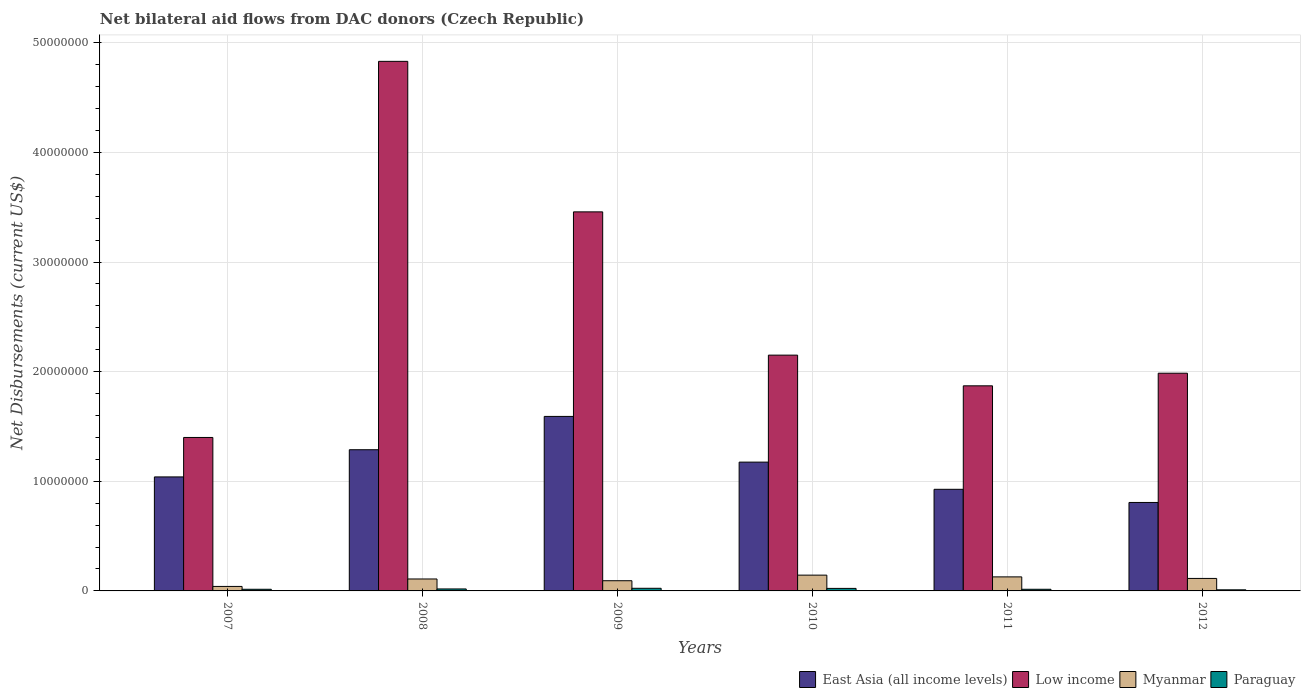How many different coloured bars are there?
Ensure brevity in your answer.  4. How many groups of bars are there?
Offer a very short reply. 6. Are the number of bars per tick equal to the number of legend labels?
Offer a very short reply. Yes. What is the label of the 1st group of bars from the left?
Provide a short and direct response. 2007. What is the net bilateral aid flows in East Asia (all income levels) in 2010?
Give a very brief answer. 1.18e+07. Across all years, what is the maximum net bilateral aid flows in Paraguay?
Your response must be concise. 2.40e+05. Across all years, what is the minimum net bilateral aid flows in Low income?
Offer a terse response. 1.40e+07. What is the total net bilateral aid flows in East Asia (all income levels) in the graph?
Keep it short and to the point. 6.83e+07. What is the difference between the net bilateral aid flows in East Asia (all income levels) in 2010 and that in 2011?
Keep it short and to the point. 2.48e+06. What is the difference between the net bilateral aid flows in East Asia (all income levels) in 2009 and the net bilateral aid flows in Paraguay in 2012?
Your response must be concise. 1.58e+07. What is the average net bilateral aid flows in Paraguay per year?
Provide a succinct answer. 1.75e+05. In the year 2008, what is the difference between the net bilateral aid flows in Paraguay and net bilateral aid flows in Low income?
Keep it short and to the point. -4.81e+07. In how many years, is the net bilateral aid flows in East Asia (all income levels) greater than 18000000 US$?
Make the answer very short. 0. What is the ratio of the net bilateral aid flows in Paraguay in 2009 to that in 2011?
Provide a short and direct response. 1.6. Is the net bilateral aid flows in Low income in 2009 less than that in 2012?
Make the answer very short. No. What is the difference between the highest and the second highest net bilateral aid flows in East Asia (all income levels)?
Your answer should be very brief. 3.04e+06. What is the difference between the highest and the lowest net bilateral aid flows in East Asia (all income levels)?
Make the answer very short. 7.85e+06. In how many years, is the net bilateral aid flows in Myanmar greater than the average net bilateral aid flows in Myanmar taken over all years?
Offer a very short reply. 4. Is the sum of the net bilateral aid flows in Paraguay in 2010 and 2012 greater than the maximum net bilateral aid flows in Myanmar across all years?
Give a very brief answer. No. What does the 4th bar from the left in 2009 represents?
Your answer should be compact. Paraguay. What does the 2nd bar from the right in 2007 represents?
Make the answer very short. Myanmar. How many bars are there?
Give a very brief answer. 24. How many years are there in the graph?
Offer a terse response. 6. What is the difference between two consecutive major ticks on the Y-axis?
Keep it short and to the point. 1.00e+07. Are the values on the major ticks of Y-axis written in scientific E-notation?
Keep it short and to the point. No. How many legend labels are there?
Offer a very short reply. 4. How are the legend labels stacked?
Your answer should be compact. Horizontal. What is the title of the graph?
Make the answer very short. Net bilateral aid flows from DAC donors (Czech Republic). What is the label or title of the Y-axis?
Keep it short and to the point. Net Disbursements (current US$). What is the Net Disbursements (current US$) of East Asia (all income levels) in 2007?
Provide a short and direct response. 1.04e+07. What is the Net Disbursements (current US$) in Low income in 2007?
Make the answer very short. 1.40e+07. What is the Net Disbursements (current US$) of East Asia (all income levels) in 2008?
Give a very brief answer. 1.29e+07. What is the Net Disbursements (current US$) in Low income in 2008?
Your response must be concise. 4.83e+07. What is the Net Disbursements (current US$) of Myanmar in 2008?
Offer a very short reply. 1.09e+06. What is the Net Disbursements (current US$) of Paraguay in 2008?
Offer a terse response. 1.80e+05. What is the Net Disbursements (current US$) in East Asia (all income levels) in 2009?
Provide a short and direct response. 1.59e+07. What is the Net Disbursements (current US$) in Low income in 2009?
Offer a very short reply. 3.46e+07. What is the Net Disbursements (current US$) in Myanmar in 2009?
Give a very brief answer. 9.30e+05. What is the Net Disbursements (current US$) in Paraguay in 2009?
Give a very brief answer. 2.40e+05. What is the Net Disbursements (current US$) in East Asia (all income levels) in 2010?
Your response must be concise. 1.18e+07. What is the Net Disbursements (current US$) in Low income in 2010?
Provide a succinct answer. 2.15e+07. What is the Net Disbursements (current US$) of Myanmar in 2010?
Provide a succinct answer. 1.44e+06. What is the Net Disbursements (current US$) of East Asia (all income levels) in 2011?
Make the answer very short. 9.27e+06. What is the Net Disbursements (current US$) of Low income in 2011?
Make the answer very short. 1.87e+07. What is the Net Disbursements (current US$) in Myanmar in 2011?
Give a very brief answer. 1.28e+06. What is the Net Disbursements (current US$) in Paraguay in 2011?
Your response must be concise. 1.50e+05. What is the Net Disbursements (current US$) of East Asia (all income levels) in 2012?
Make the answer very short. 8.07e+06. What is the Net Disbursements (current US$) of Low income in 2012?
Offer a very short reply. 1.99e+07. What is the Net Disbursements (current US$) of Myanmar in 2012?
Your response must be concise. 1.14e+06. Across all years, what is the maximum Net Disbursements (current US$) of East Asia (all income levels)?
Your response must be concise. 1.59e+07. Across all years, what is the maximum Net Disbursements (current US$) in Low income?
Make the answer very short. 4.83e+07. Across all years, what is the maximum Net Disbursements (current US$) of Myanmar?
Provide a succinct answer. 1.44e+06. Across all years, what is the maximum Net Disbursements (current US$) in Paraguay?
Offer a very short reply. 2.40e+05. Across all years, what is the minimum Net Disbursements (current US$) of East Asia (all income levels)?
Your response must be concise. 8.07e+06. Across all years, what is the minimum Net Disbursements (current US$) of Low income?
Ensure brevity in your answer.  1.40e+07. Across all years, what is the minimum Net Disbursements (current US$) of Myanmar?
Provide a succinct answer. 4.10e+05. Across all years, what is the minimum Net Disbursements (current US$) in Paraguay?
Give a very brief answer. 1.00e+05. What is the total Net Disbursements (current US$) of East Asia (all income levels) in the graph?
Offer a very short reply. 6.83e+07. What is the total Net Disbursements (current US$) of Low income in the graph?
Your answer should be very brief. 1.57e+08. What is the total Net Disbursements (current US$) in Myanmar in the graph?
Your answer should be very brief. 6.29e+06. What is the total Net Disbursements (current US$) in Paraguay in the graph?
Keep it short and to the point. 1.05e+06. What is the difference between the Net Disbursements (current US$) of East Asia (all income levels) in 2007 and that in 2008?
Give a very brief answer. -2.48e+06. What is the difference between the Net Disbursements (current US$) in Low income in 2007 and that in 2008?
Provide a succinct answer. -3.43e+07. What is the difference between the Net Disbursements (current US$) in Myanmar in 2007 and that in 2008?
Offer a terse response. -6.80e+05. What is the difference between the Net Disbursements (current US$) in East Asia (all income levels) in 2007 and that in 2009?
Provide a succinct answer. -5.52e+06. What is the difference between the Net Disbursements (current US$) in Low income in 2007 and that in 2009?
Ensure brevity in your answer.  -2.06e+07. What is the difference between the Net Disbursements (current US$) in Myanmar in 2007 and that in 2009?
Offer a terse response. -5.20e+05. What is the difference between the Net Disbursements (current US$) of East Asia (all income levels) in 2007 and that in 2010?
Ensure brevity in your answer.  -1.35e+06. What is the difference between the Net Disbursements (current US$) in Low income in 2007 and that in 2010?
Give a very brief answer. -7.51e+06. What is the difference between the Net Disbursements (current US$) in Myanmar in 2007 and that in 2010?
Your answer should be very brief. -1.03e+06. What is the difference between the Net Disbursements (current US$) of Paraguay in 2007 and that in 2010?
Your response must be concise. -8.00e+04. What is the difference between the Net Disbursements (current US$) in East Asia (all income levels) in 2007 and that in 2011?
Offer a terse response. 1.13e+06. What is the difference between the Net Disbursements (current US$) in Low income in 2007 and that in 2011?
Give a very brief answer. -4.71e+06. What is the difference between the Net Disbursements (current US$) of Myanmar in 2007 and that in 2011?
Offer a very short reply. -8.70e+05. What is the difference between the Net Disbursements (current US$) of East Asia (all income levels) in 2007 and that in 2012?
Your response must be concise. 2.33e+06. What is the difference between the Net Disbursements (current US$) in Low income in 2007 and that in 2012?
Ensure brevity in your answer.  -5.86e+06. What is the difference between the Net Disbursements (current US$) of Myanmar in 2007 and that in 2012?
Your answer should be compact. -7.30e+05. What is the difference between the Net Disbursements (current US$) of East Asia (all income levels) in 2008 and that in 2009?
Your response must be concise. -3.04e+06. What is the difference between the Net Disbursements (current US$) of Low income in 2008 and that in 2009?
Provide a succinct answer. 1.37e+07. What is the difference between the Net Disbursements (current US$) of Paraguay in 2008 and that in 2009?
Give a very brief answer. -6.00e+04. What is the difference between the Net Disbursements (current US$) of East Asia (all income levels) in 2008 and that in 2010?
Keep it short and to the point. 1.13e+06. What is the difference between the Net Disbursements (current US$) of Low income in 2008 and that in 2010?
Provide a short and direct response. 2.68e+07. What is the difference between the Net Disbursements (current US$) in Myanmar in 2008 and that in 2010?
Offer a very short reply. -3.50e+05. What is the difference between the Net Disbursements (current US$) in Paraguay in 2008 and that in 2010?
Keep it short and to the point. -5.00e+04. What is the difference between the Net Disbursements (current US$) in East Asia (all income levels) in 2008 and that in 2011?
Provide a short and direct response. 3.61e+06. What is the difference between the Net Disbursements (current US$) of Low income in 2008 and that in 2011?
Your answer should be very brief. 2.96e+07. What is the difference between the Net Disbursements (current US$) of East Asia (all income levels) in 2008 and that in 2012?
Ensure brevity in your answer.  4.81e+06. What is the difference between the Net Disbursements (current US$) in Low income in 2008 and that in 2012?
Your response must be concise. 2.84e+07. What is the difference between the Net Disbursements (current US$) in Myanmar in 2008 and that in 2012?
Your answer should be compact. -5.00e+04. What is the difference between the Net Disbursements (current US$) in Paraguay in 2008 and that in 2012?
Offer a very short reply. 8.00e+04. What is the difference between the Net Disbursements (current US$) in East Asia (all income levels) in 2009 and that in 2010?
Provide a short and direct response. 4.17e+06. What is the difference between the Net Disbursements (current US$) of Low income in 2009 and that in 2010?
Offer a very short reply. 1.31e+07. What is the difference between the Net Disbursements (current US$) of Myanmar in 2009 and that in 2010?
Make the answer very short. -5.10e+05. What is the difference between the Net Disbursements (current US$) of East Asia (all income levels) in 2009 and that in 2011?
Make the answer very short. 6.65e+06. What is the difference between the Net Disbursements (current US$) in Low income in 2009 and that in 2011?
Keep it short and to the point. 1.59e+07. What is the difference between the Net Disbursements (current US$) of Myanmar in 2009 and that in 2011?
Your answer should be compact. -3.50e+05. What is the difference between the Net Disbursements (current US$) of Paraguay in 2009 and that in 2011?
Your response must be concise. 9.00e+04. What is the difference between the Net Disbursements (current US$) in East Asia (all income levels) in 2009 and that in 2012?
Give a very brief answer. 7.85e+06. What is the difference between the Net Disbursements (current US$) of Low income in 2009 and that in 2012?
Ensure brevity in your answer.  1.47e+07. What is the difference between the Net Disbursements (current US$) of Paraguay in 2009 and that in 2012?
Give a very brief answer. 1.40e+05. What is the difference between the Net Disbursements (current US$) of East Asia (all income levels) in 2010 and that in 2011?
Offer a very short reply. 2.48e+06. What is the difference between the Net Disbursements (current US$) of Low income in 2010 and that in 2011?
Provide a succinct answer. 2.80e+06. What is the difference between the Net Disbursements (current US$) of Myanmar in 2010 and that in 2011?
Give a very brief answer. 1.60e+05. What is the difference between the Net Disbursements (current US$) of East Asia (all income levels) in 2010 and that in 2012?
Make the answer very short. 3.68e+06. What is the difference between the Net Disbursements (current US$) of Low income in 2010 and that in 2012?
Your answer should be compact. 1.65e+06. What is the difference between the Net Disbursements (current US$) of Myanmar in 2010 and that in 2012?
Provide a succinct answer. 3.00e+05. What is the difference between the Net Disbursements (current US$) of Paraguay in 2010 and that in 2012?
Offer a terse response. 1.30e+05. What is the difference between the Net Disbursements (current US$) in East Asia (all income levels) in 2011 and that in 2012?
Make the answer very short. 1.20e+06. What is the difference between the Net Disbursements (current US$) in Low income in 2011 and that in 2012?
Give a very brief answer. -1.15e+06. What is the difference between the Net Disbursements (current US$) in Myanmar in 2011 and that in 2012?
Provide a short and direct response. 1.40e+05. What is the difference between the Net Disbursements (current US$) in East Asia (all income levels) in 2007 and the Net Disbursements (current US$) in Low income in 2008?
Your answer should be compact. -3.79e+07. What is the difference between the Net Disbursements (current US$) of East Asia (all income levels) in 2007 and the Net Disbursements (current US$) of Myanmar in 2008?
Your answer should be compact. 9.31e+06. What is the difference between the Net Disbursements (current US$) in East Asia (all income levels) in 2007 and the Net Disbursements (current US$) in Paraguay in 2008?
Provide a short and direct response. 1.02e+07. What is the difference between the Net Disbursements (current US$) in Low income in 2007 and the Net Disbursements (current US$) in Myanmar in 2008?
Your response must be concise. 1.29e+07. What is the difference between the Net Disbursements (current US$) of Low income in 2007 and the Net Disbursements (current US$) of Paraguay in 2008?
Your answer should be very brief. 1.38e+07. What is the difference between the Net Disbursements (current US$) of East Asia (all income levels) in 2007 and the Net Disbursements (current US$) of Low income in 2009?
Provide a short and direct response. -2.42e+07. What is the difference between the Net Disbursements (current US$) of East Asia (all income levels) in 2007 and the Net Disbursements (current US$) of Myanmar in 2009?
Offer a very short reply. 9.47e+06. What is the difference between the Net Disbursements (current US$) in East Asia (all income levels) in 2007 and the Net Disbursements (current US$) in Paraguay in 2009?
Your answer should be compact. 1.02e+07. What is the difference between the Net Disbursements (current US$) of Low income in 2007 and the Net Disbursements (current US$) of Myanmar in 2009?
Give a very brief answer. 1.31e+07. What is the difference between the Net Disbursements (current US$) of Low income in 2007 and the Net Disbursements (current US$) of Paraguay in 2009?
Your answer should be compact. 1.38e+07. What is the difference between the Net Disbursements (current US$) in East Asia (all income levels) in 2007 and the Net Disbursements (current US$) in Low income in 2010?
Keep it short and to the point. -1.11e+07. What is the difference between the Net Disbursements (current US$) in East Asia (all income levels) in 2007 and the Net Disbursements (current US$) in Myanmar in 2010?
Keep it short and to the point. 8.96e+06. What is the difference between the Net Disbursements (current US$) in East Asia (all income levels) in 2007 and the Net Disbursements (current US$) in Paraguay in 2010?
Keep it short and to the point. 1.02e+07. What is the difference between the Net Disbursements (current US$) of Low income in 2007 and the Net Disbursements (current US$) of Myanmar in 2010?
Ensure brevity in your answer.  1.26e+07. What is the difference between the Net Disbursements (current US$) in Low income in 2007 and the Net Disbursements (current US$) in Paraguay in 2010?
Keep it short and to the point. 1.38e+07. What is the difference between the Net Disbursements (current US$) in Myanmar in 2007 and the Net Disbursements (current US$) in Paraguay in 2010?
Give a very brief answer. 1.80e+05. What is the difference between the Net Disbursements (current US$) of East Asia (all income levels) in 2007 and the Net Disbursements (current US$) of Low income in 2011?
Keep it short and to the point. -8.31e+06. What is the difference between the Net Disbursements (current US$) in East Asia (all income levels) in 2007 and the Net Disbursements (current US$) in Myanmar in 2011?
Offer a terse response. 9.12e+06. What is the difference between the Net Disbursements (current US$) in East Asia (all income levels) in 2007 and the Net Disbursements (current US$) in Paraguay in 2011?
Your answer should be compact. 1.02e+07. What is the difference between the Net Disbursements (current US$) of Low income in 2007 and the Net Disbursements (current US$) of Myanmar in 2011?
Offer a terse response. 1.27e+07. What is the difference between the Net Disbursements (current US$) in Low income in 2007 and the Net Disbursements (current US$) in Paraguay in 2011?
Provide a succinct answer. 1.38e+07. What is the difference between the Net Disbursements (current US$) of East Asia (all income levels) in 2007 and the Net Disbursements (current US$) of Low income in 2012?
Keep it short and to the point. -9.46e+06. What is the difference between the Net Disbursements (current US$) in East Asia (all income levels) in 2007 and the Net Disbursements (current US$) in Myanmar in 2012?
Keep it short and to the point. 9.26e+06. What is the difference between the Net Disbursements (current US$) in East Asia (all income levels) in 2007 and the Net Disbursements (current US$) in Paraguay in 2012?
Make the answer very short. 1.03e+07. What is the difference between the Net Disbursements (current US$) in Low income in 2007 and the Net Disbursements (current US$) in Myanmar in 2012?
Offer a terse response. 1.29e+07. What is the difference between the Net Disbursements (current US$) of Low income in 2007 and the Net Disbursements (current US$) of Paraguay in 2012?
Your response must be concise. 1.39e+07. What is the difference between the Net Disbursements (current US$) in East Asia (all income levels) in 2008 and the Net Disbursements (current US$) in Low income in 2009?
Provide a succinct answer. -2.17e+07. What is the difference between the Net Disbursements (current US$) in East Asia (all income levels) in 2008 and the Net Disbursements (current US$) in Myanmar in 2009?
Keep it short and to the point. 1.20e+07. What is the difference between the Net Disbursements (current US$) of East Asia (all income levels) in 2008 and the Net Disbursements (current US$) of Paraguay in 2009?
Your answer should be very brief. 1.26e+07. What is the difference between the Net Disbursements (current US$) of Low income in 2008 and the Net Disbursements (current US$) of Myanmar in 2009?
Offer a terse response. 4.74e+07. What is the difference between the Net Disbursements (current US$) of Low income in 2008 and the Net Disbursements (current US$) of Paraguay in 2009?
Your answer should be compact. 4.81e+07. What is the difference between the Net Disbursements (current US$) of Myanmar in 2008 and the Net Disbursements (current US$) of Paraguay in 2009?
Your response must be concise. 8.50e+05. What is the difference between the Net Disbursements (current US$) in East Asia (all income levels) in 2008 and the Net Disbursements (current US$) in Low income in 2010?
Make the answer very short. -8.63e+06. What is the difference between the Net Disbursements (current US$) of East Asia (all income levels) in 2008 and the Net Disbursements (current US$) of Myanmar in 2010?
Your response must be concise. 1.14e+07. What is the difference between the Net Disbursements (current US$) of East Asia (all income levels) in 2008 and the Net Disbursements (current US$) of Paraguay in 2010?
Offer a terse response. 1.26e+07. What is the difference between the Net Disbursements (current US$) of Low income in 2008 and the Net Disbursements (current US$) of Myanmar in 2010?
Offer a very short reply. 4.69e+07. What is the difference between the Net Disbursements (current US$) of Low income in 2008 and the Net Disbursements (current US$) of Paraguay in 2010?
Provide a succinct answer. 4.81e+07. What is the difference between the Net Disbursements (current US$) in Myanmar in 2008 and the Net Disbursements (current US$) in Paraguay in 2010?
Your response must be concise. 8.60e+05. What is the difference between the Net Disbursements (current US$) in East Asia (all income levels) in 2008 and the Net Disbursements (current US$) in Low income in 2011?
Give a very brief answer. -5.83e+06. What is the difference between the Net Disbursements (current US$) of East Asia (all income levels) in 2008 and the Net Disbursements (current US$) of Myanmar in 2011?
Make the answer very short. 1.16e+07. What is the difference between the Net Disbursements (current US$) of East Asia (all income levels) in 2008 and the Net Disbursements (current US$) of Paraguay in 2011?
Offer a very short reply. 1.27e+07. What is the difference between the Net Disbursements (current US$) in Low income in 2008 and the Net Disbursements (current US$) in Myanmar in 2011?
Keep it short and to the point. 4.70e+07. What is the difference between the Net Disbursements (current US$) in Low income in 2008 and the Net Disbursements (current US$) in Paraguay in 2011?
Keep it short and to the point. 4.82e+07. What is the difference between the Net Disbursements (current US$) of Myanmar in 2008 and the Net Disbursements (current US$) of Paraguay in 2011?
Keep it short and to the point. 9.40e+05. What is the difference between the Net Disbursements (current US$) in East Asia (all income levels) in 2008 and the Net Disbursements (current US$) in Low income in 2012?
Your response must be concise. -6.98e+06. What is the difference between the Net Disbursements (current US$) of East Asia (all income levels) in 2008 and the Net Disbursements (current US$) of Myanmar in 2012?
Keep it short and to the point. 1.17e+07. What is the difference between the Net Disbursements (current US$) in East Asia (all income levels) in 2008 and the Net Disbursements (current US$) in Paraguay in 2012?
Ensure brevity in your answer.  1.28e+07. What is the difference between the Net Disbursements (current US$) of Low income in 2008 and the Net Disbursements (current US$) of Myanmar in 2012?
Provide a short and direct response. 4.72e+07. What is the difference between the Net Disbursements (current US$) in Low income in 2008 and the Net Disbursements (current US$) in Paraguay in 2012?
Make the answer very short. 4.82e+07. What is the difference between the Net Disbursements (current US$) of Myanmar in 2008 and the Net Disbursements (current US$) of Paraguay in 2012?
Make the answer very short. 9.90e+05. What is the difference between the Net Disbursements (current US$) of East Asia (all income levels) in 2009 and the Net Disbursements (current US$) of Low income in 2010?
Offer a terse response. -5.59e+06. What is the difference between the Net Disbursements (current US$) in East Asia (all income levels) in 2009 and the Net Disbursements (current US$) in Myanmar in 2010?
Offer a very short reply. 1.45e+07. What is the difference between the Net Disbursements (current US$) in East Asia (all income levels) in 2009 and the Net Disbursements (current US$) in Paraguay in 2010?
Keep it short and to the point. 1.57e+07. What is the difference between the Net Disbursements (current US$) in Low income in 2009 and the Net Disbursements (current US$) in Myanmar in 2010?
Your answer should be compact. 3.31e+07. What is the difference between the Net Disbursements (current US$) in Low income in 2009 and the Net Disbursements (current US$) in Paraguay in 2010?
Your answer should be compact. 3.44e+07. What is the difference between the Net Disbursements (current US$) in East Asia (all income levels) in 2009 and the Net Disbursements (current US$) in Low income in 2011?
Offer a very short reply. -2.79e+06. What is the difference between the Net Disbursements (current US$) in East Asia (all income levels) in 2009 and the Net Disbursements (current US$) in Myanmar in 2011?
Your response must be concise. 1.46e+07. What is the difference between the Net Disbursements (current US$) of East Asia (all income levels) in 2009 and the Net Disbursements (current US$) of Paraguay in 2011?
Provide a succinct answer. 1.58e+07. What is the difference between the Net Disbursements (current US$) of Low income in 2009 and the Net Disbursements (current US$) of Myanmar in 2011?
Offer a very short reply. 3.33e+07. What is the difference between the Net Disbursements (current US$) of Low income in 2009 and the Net Disbursements (current US$) of Paraguay in 2011?
Your answer should be very brief. 3.44e+07. What is the difference between the Net Disbursements (current US$) in Myanmar in 2009 and the Net Disbursements (current US$) in Paraguay in 2011?
Keep it short and to the point. 7.80e+05. What is the difference between the Net Disbursements (current US$) of East Asia (all income levels) in 2009 and the Net Disbursements (current US$) of Low income in 2012?
Make the answer very short. -3.94e+06. What is the difference between the Net Disbursements (current US$) of East Asia (all income levels) in 2009 and the Net Disbursements (current US$) of Myanmar in 2012?
Provide a succinct answer. 1.48e+07. What is the difference between the Net Disbursements (current US$) of East Asia (all income levels) in 2009 and the Net Disbursements (current US$) of Paraguay in 2012?
Offer a terse response. 1.58e+07. What is the difference between the Net Disbursements (current US$) in Low income in 2009 and the Net Disbursements (current US$) in Myanmar in 2012?
Offer a terse response. 3.34e+07. What is the difference between the Net Disbursements (current US$) in Low income in 2009 and the Net Disbursements (current US$) in Paraguay in 2012?
Your answer should be compact. 3.45e+07. What is the difference between the Net Disbursements (current US$) of Myanmar in 2009 and the Net Disbursements (current US$) of Paraguay in 2012?
Keep it short and to the point. 8.30e+05. What is the difference between the Net Disbursements (current US$) in East Asia (all income levels) in 2010 and the Net Disbursements (current US$) in Low income in 2011?
Offer a very short reply. -6.96e+06. What is the difference between the Net Disbursements (current US$) of East Asia (all income levels) in 2010 and the Net Disbursements (current US$) of Myanmar in 2011?
Your answer should be very brief. 1.05e+07. What is the difference between the Net Disbursements (current US$) in East Asia (all income levels) in 2010 and the Net Disbursements (current US$) in Paraguay in 2011?
Your answer should be compact. 1.16e+07. What is the difference between the Net Disbursements (current US$) in Low income in 2010 and the Net Disbursements (current US$) in Myanmar in 2011?
Your answer should be compact. 2.02e+07. What is the difference between the Net Disbursements (current US$) in Low income in 2010 and the Net Disbursements (current US$) in Paraguay in 2011?
Offer a very short reply. 2.14e+07. What is the difference between the Net Disbursements (current US$) in Myanmar in 2010 and the Net Disbursements (current US$) in Paraguay in 2011?
Offer a terse response. 1.29e+06. What is the difference between the Net Disbursements (current US$) of East Asia (all income levels) in 2010 and the Net Disbursements (current US$) of Low income in 2012?
Offer a very short reply. -8.11e+06. What is the difference between the Net Disbursements (current US$) in East Asia (all income levels) in 2010 and the Net Disbursements (current US$) in Myanmar in 2012?
Make the answer very short. 1.06e+07. What is the difference between the Net Disbursements (current US$) in East Asia (all income levels) in 2010 and the Net Disbursements (current US$) in Paraguay in 2012?
Make the answer very short. 1.16e+07. What is the difference between the Net Disbursements (current US$) of Low income in 2010 and the Net Disbursements (current US$) of Myanmar in 2012?
Your answer should be very brief. 2.04e+07. What is the difference between the Net Disbursements (current US$) in Low income in 2010 and the Net Disbursements (current US$) in Paraguay in 2012?
Your answer should be very brief. 2.14e+07. What is the difference between the Net Disbursements (current US$) of Myanmar in 2010 and the Net Disbursements (current US$) of Paraguay in 2012?
Your response must be concise. 1.34e+06. What is the difference between the Net Disbursements (current US$) in East Asia (all income levels) in 2011 and the Net Disbursements (current US$) in Low income in 2012?
Provide a succinct answer. -1.06e+07. What is the difference between the Net Disbursements (current US$) in East Asia (all income levels) in 2011 and the Net Disbursements (current US$) in Myanmar in 2012?
Give a very brief answer. 8.13e+06. What is the difference between the Net Disbursements (current US$) in East Asia (all income levels) in 2011 and the Net Disbursements (current US$) in Paraguay in 2012?
Make the answer very short. 9.17e+06. What is the difference between the Net Disbursements (current US$) of Low income in 2011 and the Net Disbursements (current US$) of Myanmar in 2012?
Your answer should be compact. 1.76e+07. What is the difference between the Net Disbursements (current US$) of Low income in 2011 and the Net Disbursements (current US$) of Paraguay in 2012?
Your response must be concise. 1.86e+07. What is the difference between the Net Disbursements (current US$) of Myanmar in 2011 and the Net Disbursements (current US$) of Paraguay in 2012?
Ensure brevity in your answer.  1.18e+06. What is the average Net Disbursements (current US$) of East Asia (all income levels) per year?
Keep it short and to the point. 1.14e+07. What is the average Net Disbursements (current US$) of Low income per year?
Keep it short and to the point. 2.62e+07. What is the average Net Disbursements (current US$) in Myanmar per year?
Your response must be concise. 1.05e+06. What is the average Net Disbursements (current US$) of Paraguay per year?
Provide a short and direct response. 1.75e+05. In the year 2007, what is the difference between the Net Disbursements (current US$) in East Asia (all income levels) and Net Disbursements (current US$) in Low income?
Provide a short and direct response. -3.60e+06. In the year 2007, what is the difference between the Net Disbursements (current US$) of East Asia (all income levels) and Net Disbursements (current US$) of Myanmar?
Give a very brief answer. 9.99e+06. In the year 2007, what is the difference between the Net Disbursements (current US$) in East Asia (all income levels) and Net Disbursements (current US$) in Paraguay?
Offer a very short reply. 1.02e+07. In the year 2007, what is the difference between the Net Disbursements (current US$) of Low income and Net Disbursements (current US$) of Myanmar?
Keep it short and to the point. 1.36e+07. In the year 2007, what is the difference between the Net Disbursements (current US$) in Low income and Net Disbursements (current US$) in Paraguay?
Your answer should be compact. 1.38e+07. In the year 2008, what is the difference between the Net Disbursements (current US$) in East Asia (all income levels) and Net Disbursements (current US$) in Low income?
Your answer should be compact. -3.54e+07. In the year 2008, what is the difference between the Net Disbursements (current US$) in East Asia (all income levels) and Net Disbursements (current US$) in Myanmar?
Offer a terse response. 1.18e+07. In the year 2008, what is the difference between the Net Disbursements (current US$) of East Asia (all income levels) and Net Disbursements (current US$) of Paraguay?
Keep it short and to the point. 1.27e+07. In the year 2008, what is the difference between the Net Disbursements (current US$) of Low income and Net Disbursements (current US$) of Myanmar?
Offer a very short reply. 4.72e+07. In the year 2008, what is the difference between the Net Disbursements (current US$) in Low income and Net Disbursements (current US$) in Paraguay?
Provide a short and direct response. 4.81e+07. In the year 2008, what is the difference between the Net Disbursements (current US$) in Myanmar and Net Disbursements (current US$) in Paraguay?
Offer a terse response. 9.10e+05. In the year 2009, what is the difference between the Net Disbursements (current US$) of East Asia (all income levels) and Net Disbursements (current US$) of Low income?
Keep it short and to the point. -1.87e+07. In the year 2009, what is the difference between the Net Disbursements (current US$) of East Asia (all income levels) and Net Disbursements (current US$) of Myanmar?
Make the answer very short. 1.50e+07. In the year 2009, what is the difference between the Net Disbursements (current US$) in East Asia (all income levels) and Net Disbursements (current US$) in Paraguay?
Your answer should be compact. 1.57e+07. In the year 2009, what is the difference between the Net Disbursements (current US$) in Low income and Net Disbursements (current US$) in Myanmar?
Your answer should be very brief. 3.36e+07. In the year 2009, what is the difference between the Net Disbursements (current US$) in Low income and Net Disbursements (current US$) in Paraguay?
Give a very brief answer. 3.43e+07. In the year 2009, what is the difference between the Net Disbursements (current US$) in Myanmar and Net Disbursements (current US$) in Paraguay?
Provide a succinct answer. 6.90e+05. In the year 2010, what is the difference between the Net Disbursements (current US$) in East Asia (all income levels) and Net Disbursements (current US$) in Low income?
Provide a succinct answer. -9.76e+06. In the year 2010, what is the difference between the Net Disbursements (current US$) of East Asia (all income levels) and Net Disbursements (current US$) of Myanmar?
Provide a succinct answer. 1.03e+07. In the year 2010, what is the difference between the Net Disbursements (current US$) of East Asia (all income levels) and Net Disbursements (current US$) of Paraguay?
Keep it short and to the point. 1.15e+07. In the year 2010, what is the difference between the Net Disbursements (current US$) of Low income and Net Disbursements (current US$) of Myanmar?
Offer a terse response. 2.01e+07. In the year 2010, what is the difference between the Net Disbursements (current US$) in Low income and Net Disbursements (current US$) in Paraguay?
Provide a short and direct response. 2.13e+07. In the year 2010, what is the difference between the Net Disbursements (current US$) in Myanmar and Net Disbursements (current US$) in Paraguay?
Ensure brevity in your answer.  1.21e+06. In the year 2011, what is the difference between the Net Disbursements (current US$) of East Asia (all income levels) and Net Disbursements (current US$) of Low income?
Offer a terse response. -9.44e+06. In the year 2011, what is the difference between the Net Disbursements (current US$) in East Asia (all income levels) and Net Disbursements (current US$) in Myanmar?
Keep it short and to the point. 7.99e+06. In the year 2011, what is the difference between the Net Disbursements (current US$) in East Asia (all income levels) and Net Disbursements (current US$) in Paraguay?
Provide a short and direct response. 9.12e+06. In the year 2011, what is the difference between the Net Disbursements (current US$) in Low income and Net Disbursements (current US$) in Myanmar?
Provide a short and direct response. 1.74e+07. In the year 2011, what is the difference between the Net Disbursements (current US$) in Low income and Net Disbursements (current US$) in Paraguay?
Your response must be concise. 1.86e+07. In the year 2011, what is the difference between the Net Disbursements (current US$) of Myanmar and Net Disbursements (current US$) of Paraguay?
Provide a short and direct response. 1.13e+06. In the year 2012, what is the difference between the Net Disbursements (current US$) in East Asia (all income levels) and Net Disbursements (current US$) in Low income?
Give a very brief answer. -1.18e+07. In the year 2012, what is the difference between the Net Disbursements (current US$) of East Asia (all income levels) and Net Disbursements (current US$) of Myanmar?
Provide a short and direct response. 6.93e+06. In the year 2012, what is the difference between the Net Disbursements (current US$) of East Asia (all income levels) and Net Disbursements (current US$) of Paraguay?
Offer a very short reply. 7.97e+06. In the year 2012, what is the difference between the Net Disbursements (current US$) of Low income and Net Disbursements (current US$) of Myanmar?
Provide a short and direct response. 1.87e+07. In the year 2012, what is the difference between the Net Disbursements (current US$) of Low income and Net Disbursements (current US$) of Paraguay?
Keep it short and to the point. 1.98e+07. In the year 2012, what is the difference between the Net Disbursements (current US$) in Myanmar and Net Disbursements (current US$) in Paraguay?
Provide a succinct answer. 1.04e+06. What is the ratio of the Net Disbursements (current US$) in East Asia (all income levels) in 2007 to that in 2008?
Give a very brief answer. 0.81. What is the ratio of the Net Disbursements (current US$) in Low income in 2007 to that in 2008?
Keep it short and to the point. 0.29. What is the ratio of the Net Disbursements (current US$) of Myanmar in 2007 to that in 2008?
Give a very brief answer. 0.38. What is the ratio of the Net Disbursements (current US$) in East Asia (all income levels) in 2007 to that in 2009?
Your answer should be very brief. 0.65. What is the ratio of the Net Disbursements (current US$) of Low income in 2007 to that in 2009?
Ensure brevity in your answer.  0.4. What is the ratio of the Net Disbursements (current US$) of Myanmar in 2007 to that in 2009?
Offer a very short reply. 0.44. What is the ratio of the Net Disbursements (current US$) of East Asia (all income levels) in 2007 to that in 2010?
Keep it short and to the point. 0.89. What is the ratio of the Net Disbursements (current US$) of Low income in 2007 to that in 2010?
Make the answer very short. 0.65. What is the ratio of the Net Disbursements (current US$) in Myanmar in 2007 to that in 2010?
Offer a very short reply. 0.28. What is the ratio of the Net Disbursements (current US$) in Paraguay in 2007 to that in 2010?
Keep it short and to the point. 0.65. What is the ratio of the Net Disbursements (current US$) in East Asia (all income levels) in 2007 to that in 2011?
Make the answer very short. 1.12. What is the ratio of the Net Disbursements (current US$) of Low income in 2007 to that in 2011?
Offer a terse response. 0.75. What is the ratio of the Net Disbursements (current US$) of Myanmar in 2007 to that in 2011?
Your answer should be very brief. 0.32. What is the ratio of the Net Disbursements (current US$) in East Asia (all income levels) in 2007 to that in 2012?
Your response must be concise. 1.29. What is the ratio of the Net Disbursements (current US$) in Low income in 2007 to that in 2012?
Give a very brief answer. 0.7. What is the ratio of the Net Disbursements (current US$) of Myanmar in 2007 to that in 2012?
Your answer should be compact. 0.36. What is the ratio of the Net Disbursements (current US$) in Paraguay in 2007 to that in 2012?
Your answer should be very brief. 1.5. What is the ratio of the Net Disbursements (current US$) in East Asia (all income levels) in 2008 to that in 2009?
Provide a succinct answer. 0.81. What is the ratio of the Net Disbursements (current US$) of Low income in 2008 to that in 2009?
Offer a very short reply. 1.4. What is the ratio of the Net Disbursements (current US$) of Myanmar in 2008 to that in 2009?
Your answer should be compact. 1.17. What is the ratio of the Net Disbursements (current US$) of East Asia (all income levels) in 2008 to that in 2010?
Offer a terse response. 1.1. What is the ratio of the Net Disbursements (current US$) in Low income in 2008 to that in 2010?
Keep it short and to the point. 2.25. What is the ratio of the Net Disbursements (current US$) in Myanmar in 2008 to that in 2010?
Your answer should be very brief. 0.76. What is the ratio of the Net Disbursements (current US$) of Paraguay in 2008 to that in 2010?
Ensure brevity in your answer.  0.78. What is the ratio of the Net Disbursements (current US$) of East Asia (all income levels) in 2008 to that in 2011?
Provide a short and direct response. 1.39. What is the ratio of the Net Disbursements (current US$) in Low income in 2008 to that in 2011?
Make the answer very short. 2.58. What is the ratio of the Net Disbursements (current US$) in Myanmar in 2008 to that in 2011?
Offer a terse response. 0.85. What is the ratio of the Net Disbursements (current US$) in East Asia (all income levels) in 2008 to that in 2012?
Your answer should be compact. 1.6. What is the ratio of the Net Disbursements (current US$) of Low income in 2008 to that in 2012?
Offer a very short reply. 2.43. What is the ratio of the Net Disbursements (current US$) of Myanmar in 2008 to that in 2012?
Your answer should be compact. 0.96. What is the ratio of the Net Disbursements (current US$) of Paraguay in 2008 to that in 2012?
Your answer should be very brief. 1.8. What is the ratio of the Net Disbursements (current US$) of East Asia (all income levels) in 2009 to that in 2010?
Provide a short and direct response. 1.35. What is the ratio of the Net Disbursements (current US$) in Low income in 2009 to that in 2010?
Ensure brevity in your answer.  1.61. What is the ratio of the Net Disbursements (current US$) in Myanmar in 2009 to that in 2010?
Offer a terse response. 0.65. What is the ratio of the Net Disbursements (current US$) of Paraguay in 2009 to that in 2010?
Make the answer very short. 1.04. What is the ratio of the Net Disbursements (current US$) in East Asia (all income levels) in 2009 to that in 2011?
Provide a short and direct response. 1.72. What is the ratio of the Net Disbursements (current US$) in Low income in 2009 to that in 2011?
Give a very brief answer. 1.85. What is the ratio of the Net Disbursements (current US$) in Myanmar in 2009 to that in 2011?
Provide a short and direct response. 0.73. What is the ratio of the Net Disbursements (current US$) of Paraguay in 2009 to that in 2011?
Keep it short and to the point. 1.6. What is the ratio of the Net Disbursements (current US$) in East Asia (all income levels) in 2009 to that in 2012?
Keep it short and to the point. 1.97. What is the ratio of the Net Disbursements (current US$) of Low income in 2009 to that in 2012?
Your answer should be compact. 1.74. What is the ratio of the Net Disbursements (current US$) in Myanmar in 2009 to that in 2012?
Your answer should be very brief. 0.82. What is the ratio of the Net Disbursements (current US$) in East Asia (all income levels) in 2010 to that in 2011?
Give a very brief answer. 1.27. What is the ratio of the Net Disbursements (current US$) of Low income in 2010 to that in 2011?
Ensure brevity in your answer.  1.15. What is the ratio of the Net Disbursements (current US$) of Myanmar in 2010 to that in 2011?
Your response must be concise. 1.12. What is the ratio of the Net Disbursements (current US$) in Paraguay in 2010 to that in 2011?
Give a very brief answer. 1.53. What is the ratio of the Net Disbursements (current US$) of East Asia (all income levels) in 2010 to that in 2012?
Provide a short and direct response. 1.46. What is the ratio of the Net Disbursements (current US$) in Low income in 2010 to that in 2012?
Your answer should be very brief. 1.08. What is the ratio of the Net Disbursements (current US$) of Myanmar in 2010 to that in 2012?
Your answer should be compact. 1.26. What is the ratio of the Net Disbursements (current US$) of Paraguay in 2010 to that in 2012?
Offer a very short reply. 2.3. What is the ratio of the Net Disbursements (current US$) of East Asia (all income levels) in 2011 to that in 2012?
Provide a succinct answer. 1.15. What is the ratio of the Net Disbursements (current US$) in Low income in 2011 to that in 2012?
Make the answer very short. 0.94. What is the ratio of the Net Disbursements (current US$) in Myanmar in 2011 to that in 2012?
Offer a very short reply. 1.12. What is the difference between the highest and the second highest Net Disbursements (current US$) of East Asia (all income levels)?
Keep it short and to the point. 3.04e+06. What is the difference between the highest and the second highest Net Disbursements (current US$) in Low income?
Ensure brevity in your answer.  1.37e+07. What is the difference between the highest and the second highest Net Disbursements (current US$) of Myanmar?
Provide a succinct answer. 1.60e+05. What is the difference between the highest and the lowest Net Disbursements (current US$) of East Asia (all income levels)?
Your answer should be compact. 7.85e+06. What is the difference between the highest and the lowest Net Disbursements (current US$) in Low income?
Make the answer very short. 3.43e+07. What is the difference between the highest and the lowest Net Disbursements (current US$) of Myanmar?
Your answer should be compact. 1.03e+06. What is the difference between the highest and the lowest Net Disbursements (current US$) of Paraguay?
Offer a very short reply. 1.40e+05. 